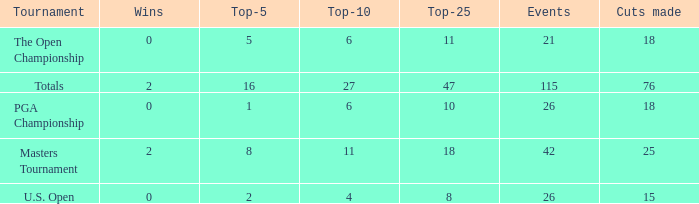What is the total of wins when the cuts made is 76 and the events greater than 115? None. 